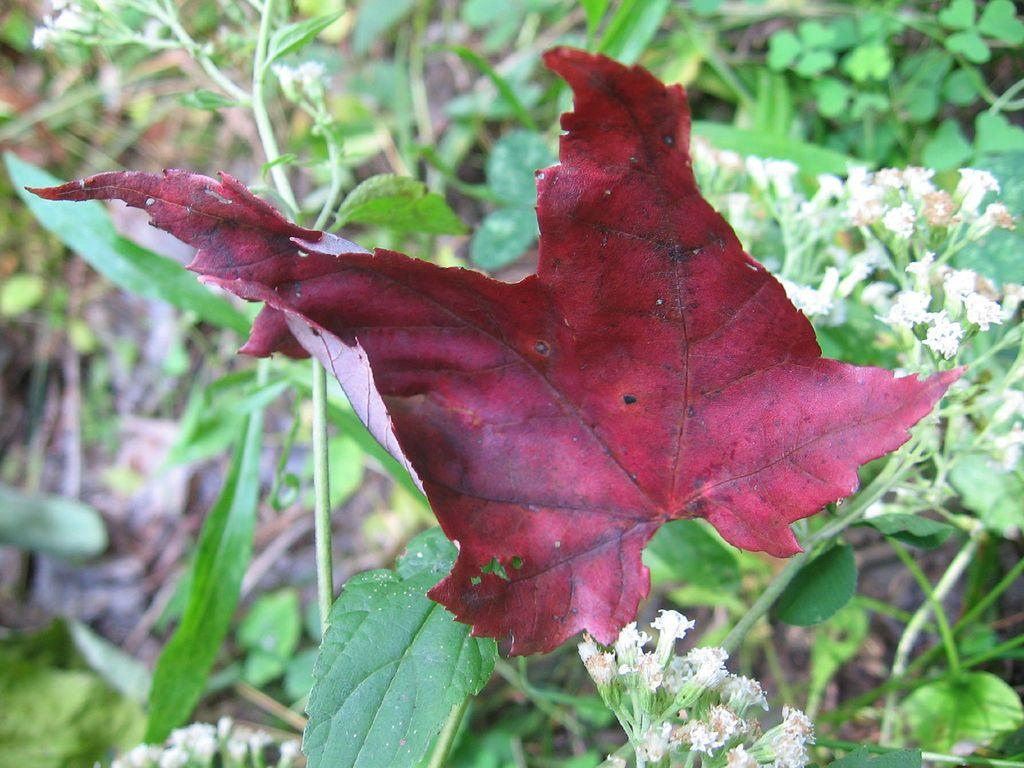What is the color of the leaf in the image? The leaf in the image is maroon in color. What other types of leaves can be seen in the image? There are green leaves in the background of the image. What other elements can be seen in the background of the image? There are white flowers in the background of the image. What type of protest is taking place in the lunchroom in the image? There is no protest or lunchroom present in the image; it features a maroon leaf and green leaves with white flowers in the background. 